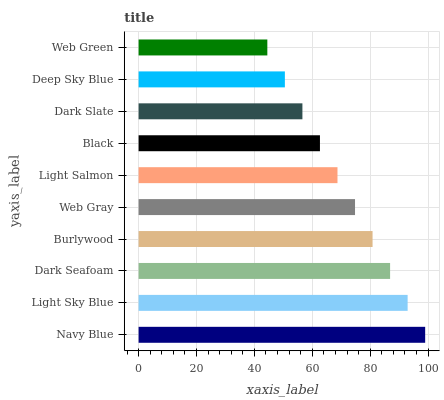Is Web Green the minimum?
Answer yes or no. Yes. Is Navy Blue the maximum?
Answer yes or no. Yes. Is Light Sky Blue the minimum?
Answer yes or no. No. Is Light Sky Blue the maximum?
Answer yes or no. No. Is Navy Blue greater than Light Sky Blue?
Answer yes or no. Yes. Is Light Sky Blue less than Navy Blue?
Answer yes or no. Yes. Is Light Sky Blue greater than Navy Blue?
Answer yes or no. No. Is Navy Blue less than Light Sky Blue?
Answer yes or no. No. Is Web Gray the high median?
Answer yes or no. Yes. Is Light Salmon the low median?
Answer yes or no. Yes. Is Deep Sky Blue the high median?
Answer yes or no. No. Is Dark Seafoam the low median?
Answer yes or no. No. 